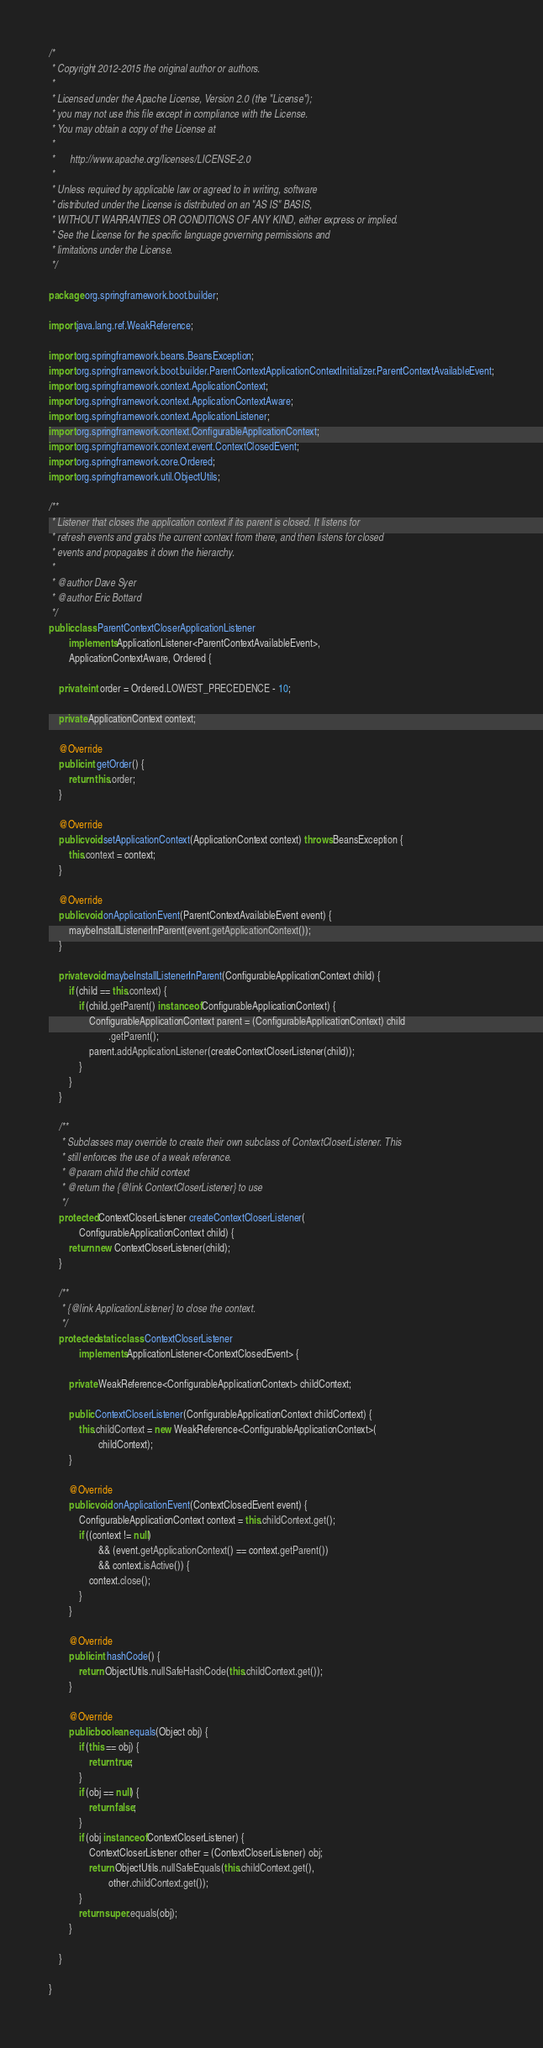Convert code to text. <code><loc_0><loc_0><loc_500><loc_500><_Java_>/*
 * Copyright 2012-2015 the original author or authors.
 *
 * Licensed under the Apache License, Version 2.0 (the "License");
 * you may not use this file except in compliance with the License.
 * You may obtain a copy of the License at
 *
 *      http://www.apache.org/licenses/LICENSE-2.0
 *
 * Unless required by applicable law or agreed to in writing, software
 * distributed under the License is distributed on an "AS IS" BASIS,
 * WITHOUT WARRANTIES OR CONDITIONS OF ANY KIND, either express or implied.
 * See the License for the specific language governing permissions and
 * limitations under the License.
 */

package org.springframework.boot.builder;

import java.lang.ref.WeakReference;

import org.springframework.beans.BeansException;
import org.springframework.boot.builder.ParentContextApplicationContextInitializer.ParentContextAvailableEvent;
import org.springframework.context.ApplicationContext;
import org.springframework.context.ApplicationContextAware;
import org.springframework.context.ApplicationListener;
import org.springframework.context.ConfigurableApplicationContext;
import org.springframework.context.event.ContextClosedEvent;
import org.springframework.core.Ordered;
import org.springframework.util.ObjectUtils;

/**
 * Listener that closes the application context if its parent is closed. It listens for
 * refresh events and grabs the current context from there, and then listens for closed
 * events and propagates it down the hierarchy.
 *
 * @author Dave Syer
 * @author Eric Bottard
 */
public class ParentContextCloserApplicationListener
		implements ApplicationListener<ParentContextAvailableEvent>,
		ApplicationContextAware, Ordered {

	private int order = Ordered.LOWEST_PRECEDENCE - 10;

	private ApplicationContext context;

	@Override
	public int getOrder() {
		return this.order;
	}

	@Override
	public void setApplicationContext(ApplicationContext context) throws BeansException {
		this.context = context;
	}

	@Override
	public void onApplicationEvent(ParentContextAvailableEvent event) {
		maybeInstallListenerInParent(event.getApplicationContext());
	}

	private void maybeInstallListenerInParent(ConfigurableApplicationContext child) {
		if (child == this.context) {
			if (child.getParent() instanceof ConfigurableApplicationContext) {
				ConfigurableApplicationContext parent = (ConfigurableApplicationContext) child
						.getParent();
				parent.addApplicationListener(createContextCloserListener(child));
			}
		}
	}

	/**
	 * Subclasses may override to create their own subclass of ContextCloserListener. This
	 * still enforces the use of a weak reference.
	 * @param child the child context
	 * @return the {@link ContextCloserListener} to use
	 */
	protected ContextCloserListener createContextCloserListener(
			ConfigurableApplicationContext child) {
		return new ContextCloserListener(child);
	}

	/**
	 * {@link ApplicationListener} to close the context.
	 */
	protected static class ContextCloserListener
			implements ApplicationListener<ContextClosedEvent> {

		private WeakReference<ConfigurableApplicationContext> childContext;

		public ContextCloserListener(ConfigurableApplicationContext childContext) {
			this.childContext = new WeakReference<ConfigurableApplicationContext>(
					childContext);
		}

		@Override
		public void onApplicationEvent(ContextClosedEvent event) {
			ConfigurableApplicationContext context = this.childContext.get();
			if ((context != null)
					&& (event.getApplicationContext() == context.getParent())
					&& context.isActive()) {
				context.close();
			}
		}

		@Override
		public int hashCode() {
			return ObjectUtils.nullSafeHashCode(this.childContext.get());
		}

		@Override
		public boolean equals(Object obj) {
			if (this == obj) {
				return true;
			}
			if (obj == null) {
				return false;
			}
			if (obj instanceof ContextCloserListener) {
				ContextCloserListener other = (ContextCloserListener) obj;
				return ObjectUtils.nullSafeEquals(this.childContext.get(),
						other.childContext.get());
			}
			return super.equals(obj);
		}

	}

}
</code> 